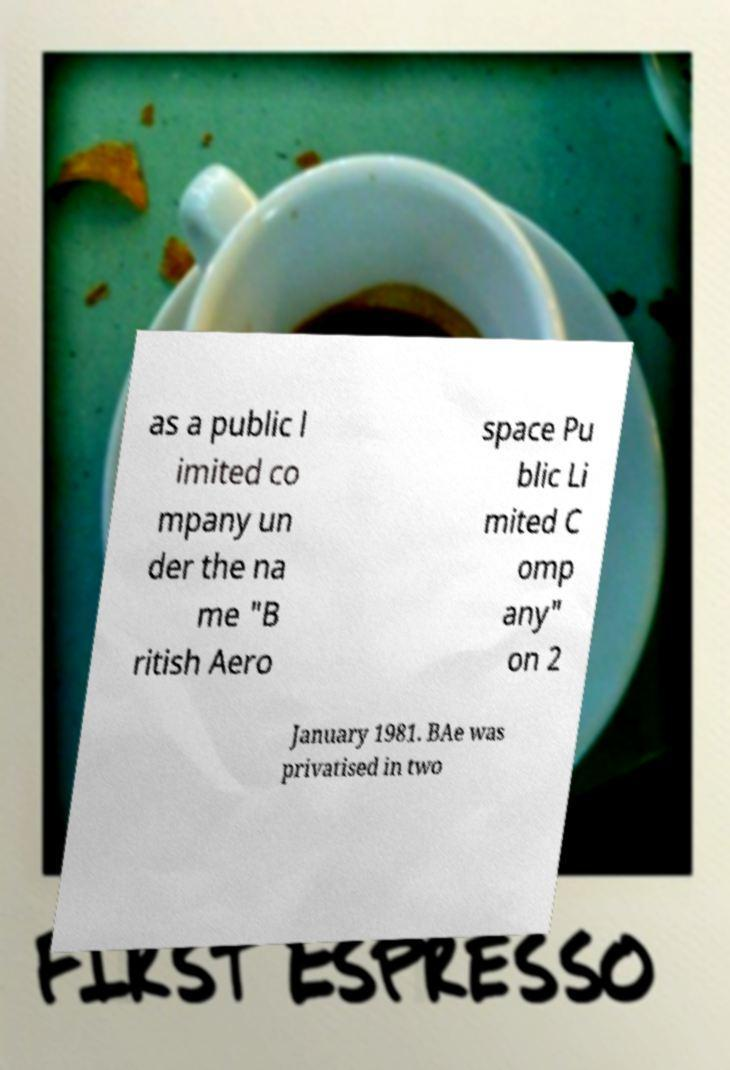Please read and relay the text visible in this image. What does it say? as a public l imited co mpany un der the na me "B ritish Aero space Pu blic Li mited C omp any" on 2 January 1981. BAe was privatised in two 